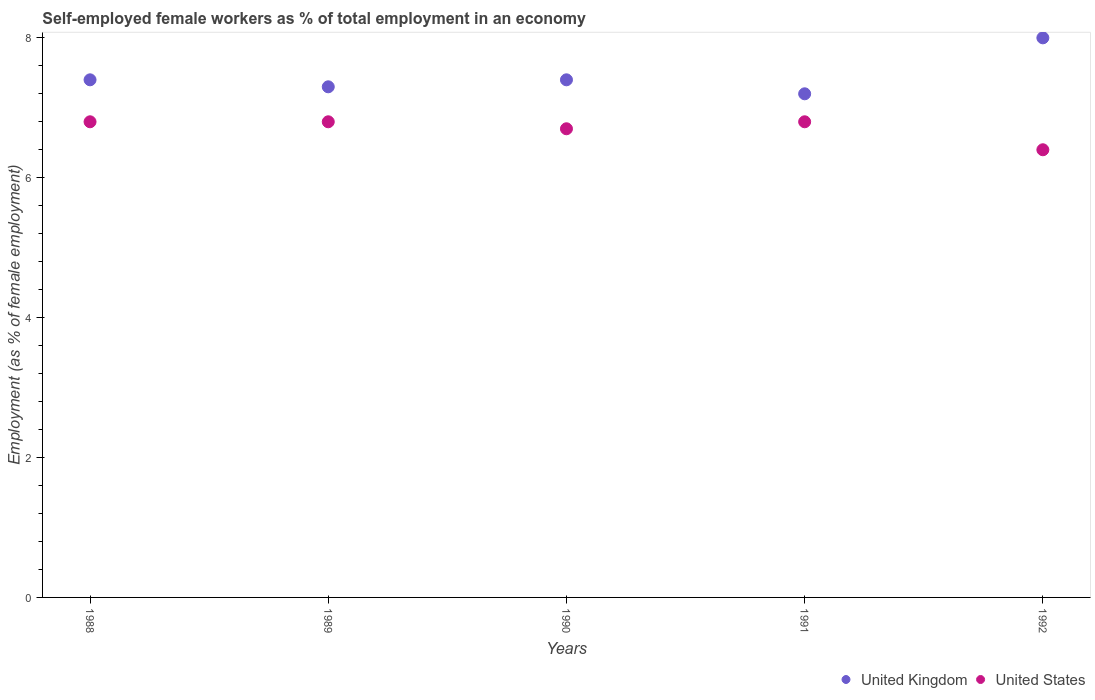How many different coloured dotlines are there?
Make the answer very short. 2. What is the percentage of self-employed female workers in United States in 1992?
Offer a very short reply. 6.4. Across all years, what is the maximum percentage of self-employed female workers in United States?
Make the answer very short. 6.8. Across all years, what is the minimum percentage of self-employed female workers in United Kingdom?
Offer a very short reply. 7.2. In which year was the percentage of self-employed female workers in United Kingdom maximum?
Your answer should be compact. 1992. In which year was the percentage of self-employed female workers in United States minimum?
Your answer should be compact. 1992. What is the total percentage of self-employed female workers in United Kingdom in the graph?
Make the answer very short. 37.3. What is the difference between the percentage of self-employed female workers in United Kingdom in 1988 and that in 1991?
Your answer should be compact. 0.2. What is the difference between the percentage of self-employed female workers in United Kingdom in 1988 and the percentage of self-employed female workers in United States in 1990?
Your response must be concise. 0.7. What is the average percentage of self-employed female workers in United States per year?
Offer a terse response. 6.7. In how many years, is the percentage of self-employed female workers in United States greater than 7.2 %?
Give a very brief answer. 0. What is the ratio of the percentage of self-employed female workers in United Kingdom in 1989 to that in 1990?
Ensure brevity in your answer.  0.99. Is the percentage of self-employed female workers in United Kingdom in 1989 less than that in 1992?
Give a very brief answer. Yes. What is the difference between the highest and the second highest percentage of self-employed female workers in United Kingdom?
Make the answer very short. 0.6. What is the difference between the highest and the lowest percentage of self-employed female workers in United States?
Provide a short and direct response. 0.4. In how many years, is the percentage of self-employed female workers in United States greater than the average percentage of self-employed female workers in United States taken over all years?
Offer a very short reply. 3. Is the sum of the percentage of self-employed female workers in United Kingdom in 1988 and 1990 greater than the maximum percentage of self-employed female workers in United States across all years?
Keep it short and to the point. Yes. Is the percentage of self-employed female workers in United Kingdom strictly less than the percentage of self-employed female workers in United States over the years?
Ensure brevity in your answer.  No. How many dotlines are there?
Provide a short and direct response. 2. What is the difference between two consecutive major ticks on the Y-axis?
Your response must be concise. 2. Are the values on the major ticks of Y-axis written in scientific E-notation?
Give a very brief answer. No. Does the graph contain any zero values?
Provide a succinct answer. No. Does the graph contain grids?
Give a very brief answer. No. How are the legend labels stacked?
Your answer should be very brief. Horizontal. What is the title of the graph?
Give a very brief answer. Self-employed female workers as % of total employment in an economy. What is the label or title of the Y-axis?
Your answer should be compact. Employment (as % of female employment). What is the Employment (as % of female employment) in United Kingdom in 1988?
Provide a short and direct response. 7.4. What is the Employment (as % of female employment) in United States in 1988?
Your response must be concise. 6.8. What is the Employment (as % of female employment) in United Kingdom in 1989?
Your response must be concise. 7.3. What is the Employment (as % of female employment) in United States in 1989?
Provide a succinct answer. 6.8. What is the Employment (as % of female employment) in United Kingdom in 1990?
Give a very brief answer. 7.4. What is the Employment (as % of female employment) in United States in 1990?
Give a very brief answer. 6.7. What is the Employment (as % of female employment) in United Kingdom in 1991?
Your answer should be very brief. 7.2. What is the Employment (as % of female employment) of United States in 1991?
Provide a short and direct response. 6.8. What is the Employment (as % of female employment) of United States in 1992?
Give a very brief answer. 6.4. Across all years, what is the maximum Employment (as % of female employment) in United Kingdom?
Keep it short and to the point. 8. Across all years, what is the maximum Employment (as % of female employment) of United States?
Offer a very short reply. 6.8. Across all years, what is the minimum Employment (as % of female employment) of United Kingdom?
Give a very brief answer. 7.2. Across all years, what is the minimum Employment (as % of female employment) in United States?
Offer a very short reply. 6.4. What is the total Employment (as % of female employment) of United Kingdom in the graph?
Offer a very short reply. 37.3. What is the total Employment (as % of female employment) in United States in the graph?
Offer a very short reply. 33.5. What is the difference between the Employment (as % of female employment) in United Kingdom in 1988 and that in 1989?
Offer a terse response. 0.1. What is the difference between the Employment (as % of female employment) in United States in 1988 and that in 1990?
Give a very brief answer. 0.1. What is the difference between the Employment (as % of female employment) of United Kingdom in 1988 and that in 1991?
Provide a succinct answer. 0.2. What is the difference between the Employment (as % of female employment) of United States in 1988 and that in 1992?
Your answer should be very brief. 0.4. What is the difference between the Employment (as % of female employment) of United Kingdom in 1989 and that in 1990?
Ensure brevity in your answer.  -0.1. What is the difference between the Employment (as % of female employment) of United Kingdom in 1989 and that in 1992?
Make the answer very short. -0.7. What is the difference between the Employment (as % of female employment) of United States in 1989 and that in 1992?
Ensure brevity in your answer.  0.4. What is the difference between the Employment (as % of female employment) in United Kingdom in 1990 and that in 1992?
Provide a short and direct response. -0.6. What is the difference between the Employment (as % of female employment) in United States in 1990 and that in 1992?
Make the answer very short. 0.3. What is the difference between the Employment (as % of female employment) of United States in 1991 and that in 1992?
Your response must be concise. 0.4. What is the difference between the Employment (as % of female employment) in United Kingdom in 1988 and the Employment (as % of female employment) in United States in 1989?
Your answer should be very brief. 0.6. What is the difference between the Employment (as % of female employment) of United Kingdom in 1988 and the Employment (as % of female employment) of United States in 1990?
Your response must be concise. 0.7. What is the difference between the Employment (as % of female employment) of United Kingdom in 1989 and the Employment (as % of female employment) of United States in 1991?
Your response must be concise. 0.5. What is the difference between the Employment (as % of female employment) of United Kingdom in 1989 and the Employment (as % of female employment) of United States in 1992?
Provide a short and direct response. 0.9. What is the difference between the Employment (as % of female employment) in United Kingdom in 1991 and the Employment (as % of female employment) in United States in 1992?
Provide a succinct answer. 0.8. What is the average Employment (as % of female employment) of United Kingdom per year?
Your answer should be compact. 7.46. In the year 1989, what is the difference between the Employment (as % of female employment) in United Kingdom and Employment (as % of female employment) in United States?
Provide a short and direct response. 0.5. In the year 1990, what is the difference between the Employment (as % of female employment) in United Kingdom and Employment (as % of female employment) in United States?
Make the answer very short. 0.7. In the year 1991, what is the difference between the Employment (as % of female employment) of United Kingdom and Employment (as % of female employment) of United States?
Provide a succinct answer. 0.4. In the year 1992, what is the difference between the Employment (as % of female employment) of United Kingdom and Employment (as % of female employment) of United States?
Ensure brevity in your answer.  1.6. What is the ratio of the Employment (as % of female employment) in United Kingdom in 1988 to that in 1989?
Make the answer very short. 1.01. What is the ratio of the Employment (as % of female employment) in United States in 1988 to that in 1989?
Your answer should be compact. 1. What is the ratio of the Employment (as % of female employment) in United Kingdom in 1988 to that in 1990?
Make the answer very short. 1. What is the ratio of the Employment (as % of female employment) of United States in 1988 to that in 1990?
Provide a succinct answer. 1.01. What is the ratio of the Employment (as % of female employment) in United Kingdom in 1988 to that in 1991?
Your response must be concise. 1.03. What is the ratio of the Employment (as % of female employment) of United States in 1988 to that in 1991?
Offer a terse response. 1. What is the ratio of the Employment (as % of female employment) in United Kingdom in 1988 to that in 1992?
Your answer should be compact. 0.93. What is the ratio of the Employment (as % of female employment) in United Kingdom in 1989 to that in 1990?
Offer a terse response. 0.99. What is the ratio of the Employment (as % of female employment) of United States in 1989 to that in 1990?
Your answer should be very brief. 1.01. What is the ratio of the Employment (as % of female employment) in United Kingdom in 1989 to that in 1991?
Provide a short and direct response. 1.01. What is the ratio of the Employment (as % of female employment) in United States in 1989 to that in 1991?
Keep it short and to the point. 1. What is the ratio of the Employment (as % of female employment) in United Kingdom in 1989 to that in 1992?
Give a very brief answer. 0.91. What is the ratio of the Employment (as % of female employment) of United States in 1989 to that in 1992?
Offer a terse response. 1.06. What is the ratio of the Employment (as % of female employment) in United Kingdom in 1990 to that in 1991?
Provide a short and direct response. 1.03. What is the ratio of the Employment (as % of female employment) of United States in 1990 to that in 1991?
Keep it short and to the point. 0.99. What is the ratio of the Employment (as % of female employment) in United Kingdom in 1990 to that in 1992?
Provide a succinct answer. 0.93. What is the ratio of the Employment (as % of female employment) of United States in 1990 to that in 1992?
Your answer should be compact. 1.05. What is the ratio of the Employment (as % of female employment) in United States in 1991 to that in 1992?
Offer a very short reply. 1.06. What is the difference between the highest and the second highest Employment (as % of female employment) of United Kingdom?
Provide a short and direct response. 0.6. What is the difference between the highest and the second highest Employment (as % of female employment) in United States?
Make the answer very short. 0. What is the difference between the highest and the lowest Employment (as % of female employment) in United Kingdom?
Offer a terse response. 0.8. What is the difference between the highest and the lowest Employment (as % of female employment) of United States?
Ensure brevity in your answer.  0.4. 